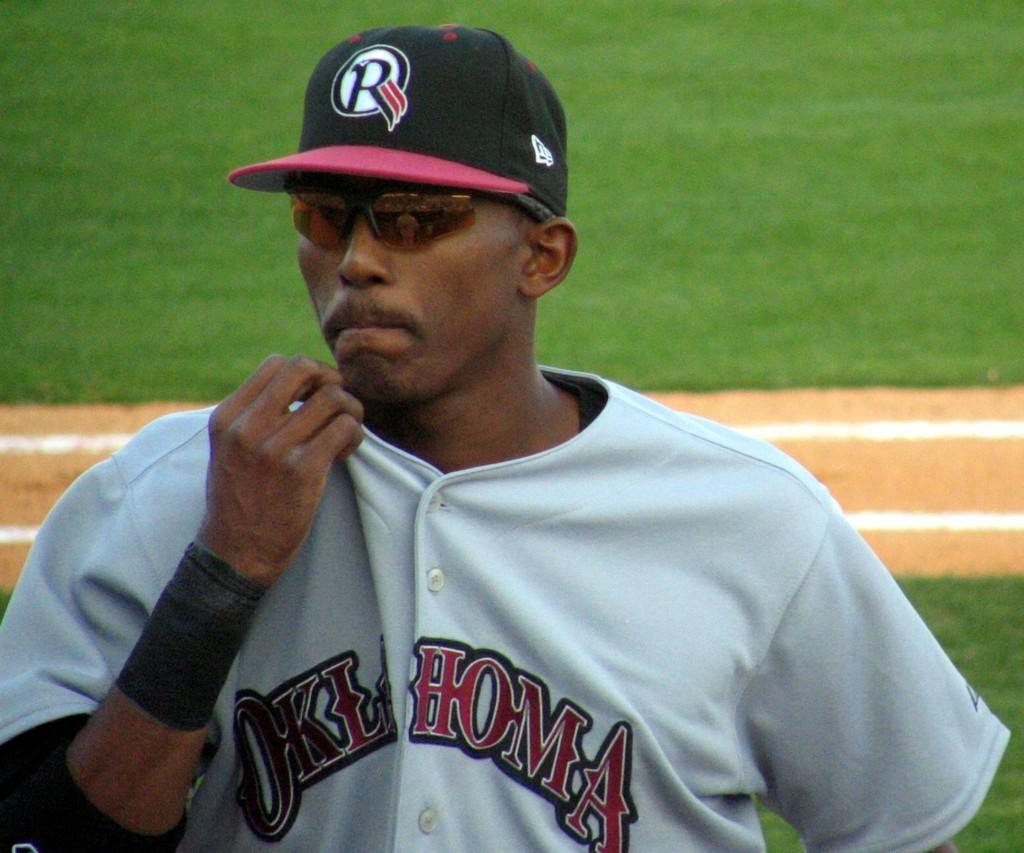<image>
Write a terse but informative summary of the picture. A player on the Oklahoma baseball team wears orange tinted sunglasses. 